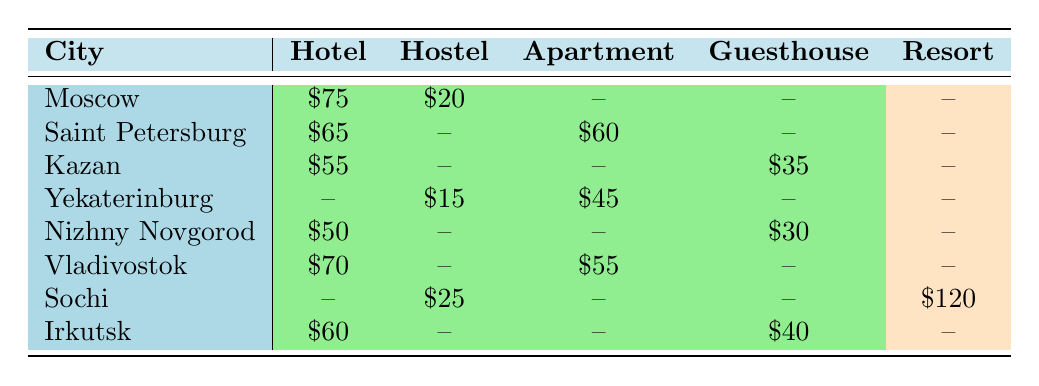What is the price per night for a hotel in Moscow? The table directly provides the information for the hotel category in Moscow. It shows a price of $75 per night.
Answer: $75 Which city has the highest price for a resort? The table indicates that Sochi has a resort, which costs $120 per night. This is the highest price listed in the table for that accommodation type.
Answer: $120 Are there any cities that have both a hotel and a guesthouse? By reviewing the table, only Kazan has both a hotel priced at $55 and a guesthouse priced at $35, confirming that there are cities with both accommodation types.
Answer: Yes What is the average price of hostels across the cities listed? The hostels in the table are in Yekaterinburg ($15) and Sochi ($25). Adding these two prices gives $40, and then dividing by 2 results in an average of $20.
Answer: $20 In which city is the price for an apartment higher than the price for a hotel? By comparing the prices in the table, Saint Petersburg has an apartment priced at $60 and a hotel priced at $65; there is no city where the apartment price exceeds the hotel price.
Answer: No How much cheaper is the guesthouse in Kazan compared to the hotel there? The guesthouse in Kazan is $35 and the hotel is $55, so the difference is $55 - $35 = $20.
Answer: $20 What is the overall cheapest accommodation option available in the cities? Looking at the prices in each accommodation type across all cities, the hostel in Yekaterinburg is the cheapest at $15 per night.
Answer: $15 Which city has the highest rated accommodation type and what is the rating? The hotel in Saint Petersburg has the highest rating of 5. This fact is evident in the ratings provided in the table alongside the accommodation prices.
Answer: 5 How many types of accommodations are listed for Saint Petersburg? The table shows two accommodation types for Saint Petersburg: hotel and apartment, totaling two types listed in the table.
Answer: 2 